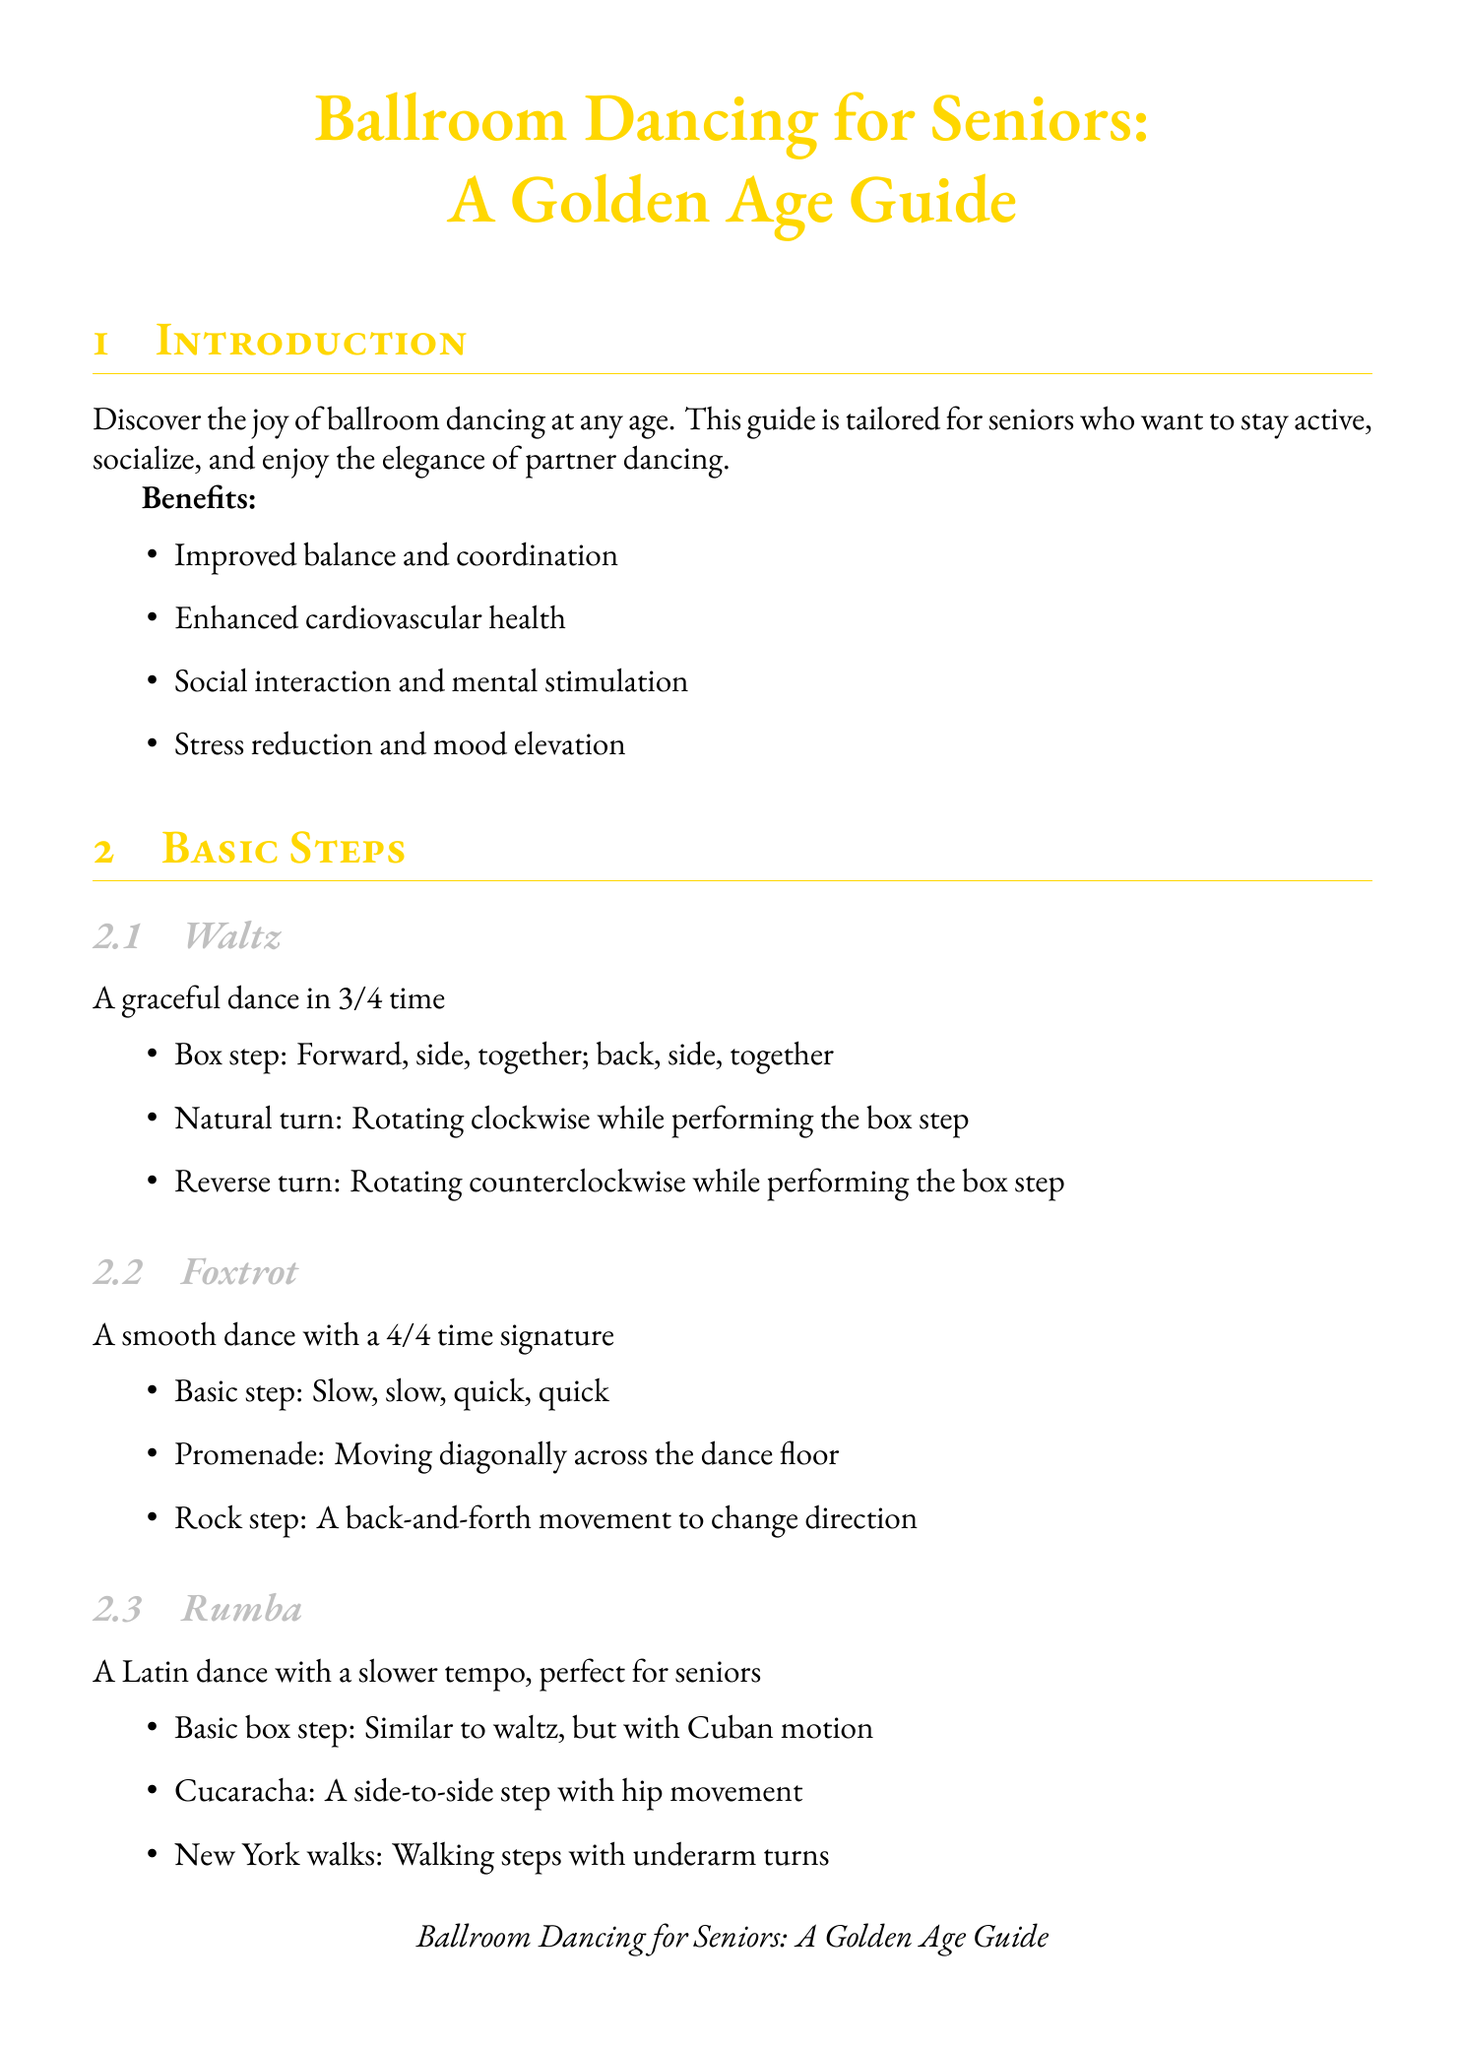What are the benefits of ballroom dancing for seniors? The benefits listed in the document include improved balance and coordination, enhanced cardiovascular health, social interaction and mental stimulation, and stress reduction and mood elevation.
Answer: Improved balance and coordination, enhanced cardiovascular health, social interaction and mental stimulation, stress reduction and mood elevation What is the basic step of the Waltz? The document outlines that the basic step of the Waltz consists of the box step: forward, side, together; back, side, together.
Answer: Box step: Forward, side, together; back, side, together Name a recommended venue for seniors to dance. The document lists multiple venues and asks for any specific one, such as Silver Slipper Dance Studio, which specializes in senior-friendly dance classes.
Answer: Silver Slipper Dance Studio How many steps are there in the Foxtrot section? The document contains three steps specifically mentioned for the Foxtrot.
Answer: Three What should seniors wear while dancing? Attire suggestions for men include a comfortable dress shirt, while women are advised to wear a flowing skirt or dress for ease of movement.
Answer: A comfortable dress shirt for men and a flowing skirt or dress for women What is one adaptive technique suggested for seniors? The document lists balance support, which is to use a chair or partner for support during practice.
Answer: Use a chair or partner for support during practice What type of music is suggested for classic ballroom dancing? The document provides examples of classic ballroom music, including "Moon River" by Henry Mancini.
Answer: "Moon River" by Henry Mancini How should partners communicate while dancing? The document mentions discussing physical limitations before dancing as an important communication aspect.
Answer: Discuss any physical limitations before dancing 